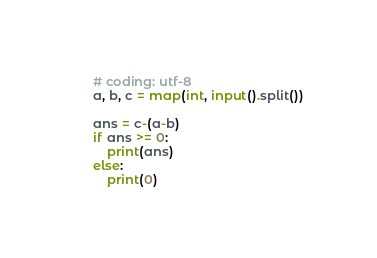Convert code to text. <code><loc_0><loc_0><loc_500><loc_500><_Python_># coding: utf-8
a, b, c = map(int, input().split())

ans = c-(a-b)
if ans >= 0:
    print(ans)
else:
    print(0)</code> 